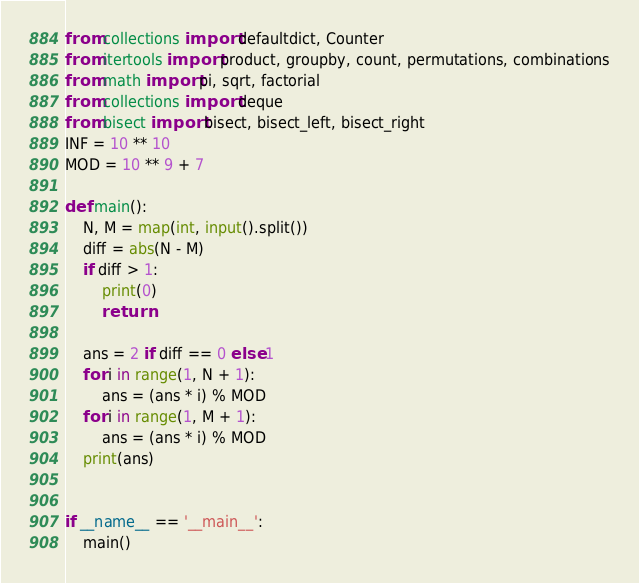Convert code to text. <code><loc_0><loc_0><loc_500><loc_500><_Python_>from collections import defaultdict, Counter
from itertools import product, groupby, count, permutations, combinations
from math import pi, sqrt, factorial
from collections import deque
from bisect import bisect, bisect_left, bisect_right
INF = 10 ** 10
MOD = 10 ** 9 + 7

def main():
    N, M = map(int, input().split())
    diff = abs(N - M)
    if diff > 1:
        print(0)
        return

    ans = 2 if diff == 0 else 1
    for i in range(1, N + 1):
        ans = (ans * i) % MOD
    for i in range(1, M + 1):
        ans = (ans * i) % MOD
    print(ans)


if __name__ == '__main__':
    main()
</code> 